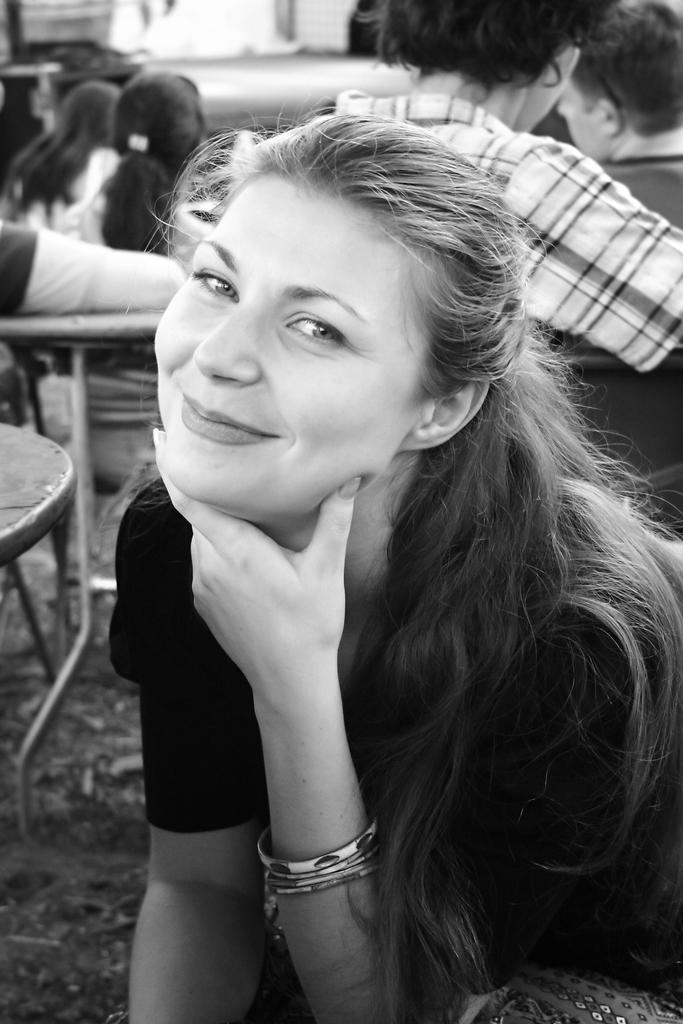What is the color scheme of the image? The image is black and white. What is the person in the image doing? The person is sitting on a chair in the image. What is the facial expression of the person? The person is smiling. Can you describe the setting in the background of the image? There is a group of people sitting on chairs in the background of the image. What type of locket is the person wearing in the image? There is no locket visible in the image. What design can be seen on the chair the person is sitting on? The image is black and white, so it is difficult to discern any specific design on the chair. 